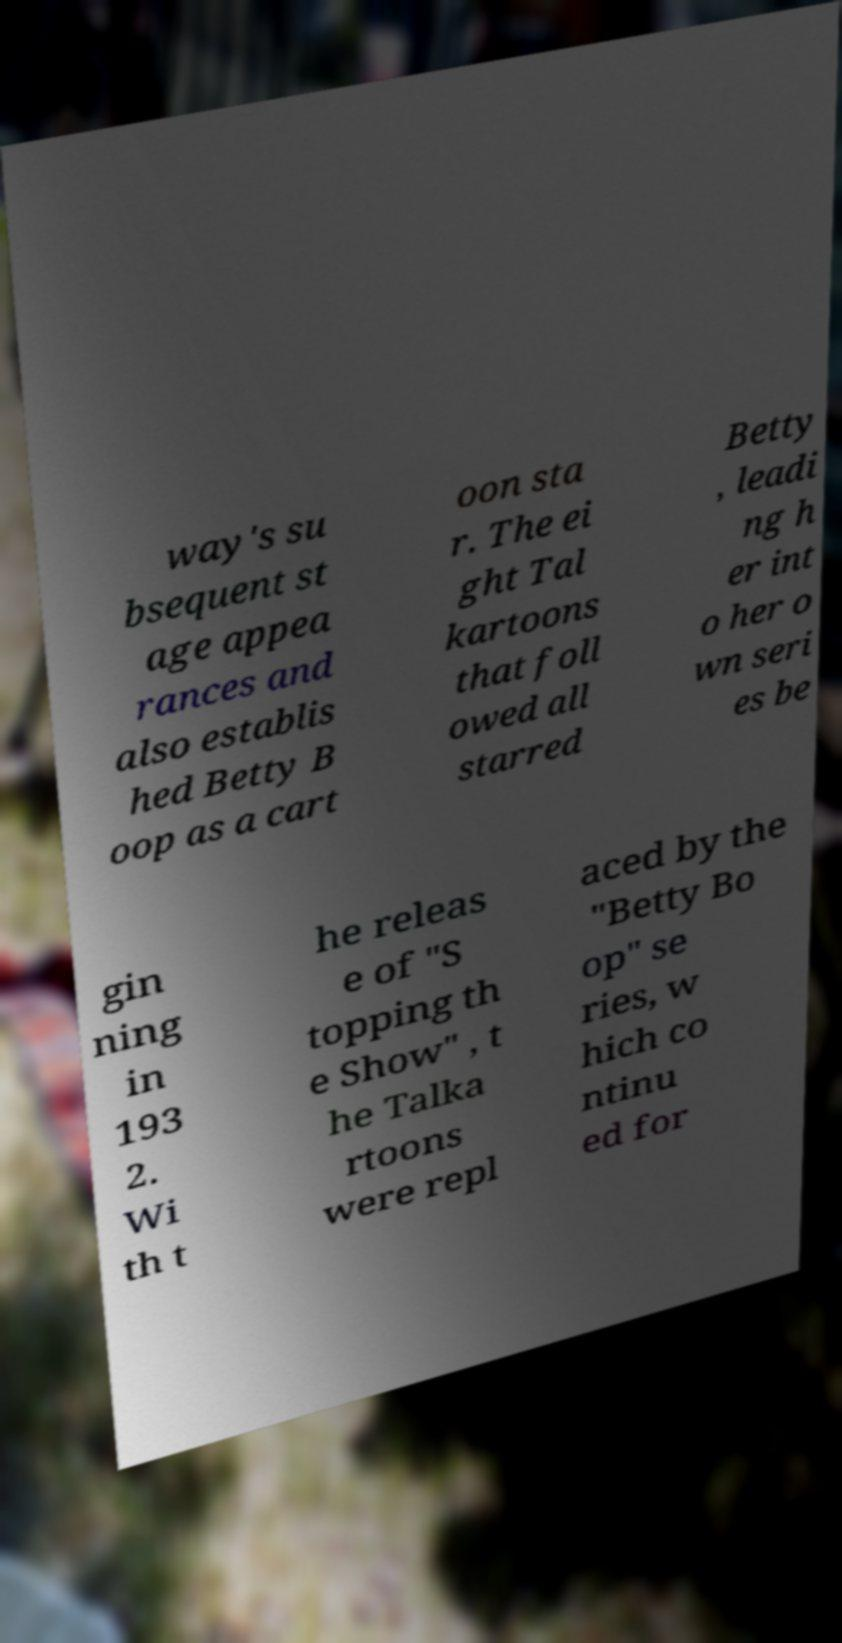Could you assist in decoding the text presented in this image and type it out clearly? way's su bsequent st age appea rances and also establis hed Betty B oop as a cart oon sta r. The ei ght Tal kartoons that foll owed all starred Betty , leadi ng h er int o her o wn seri es be gin ning in 193 2. Wi th t he releas e of "S topping th e Show" , t he Talka rtoons were repl aced by the "Betty Bo op" se ries, w hich co ntinu ed for 